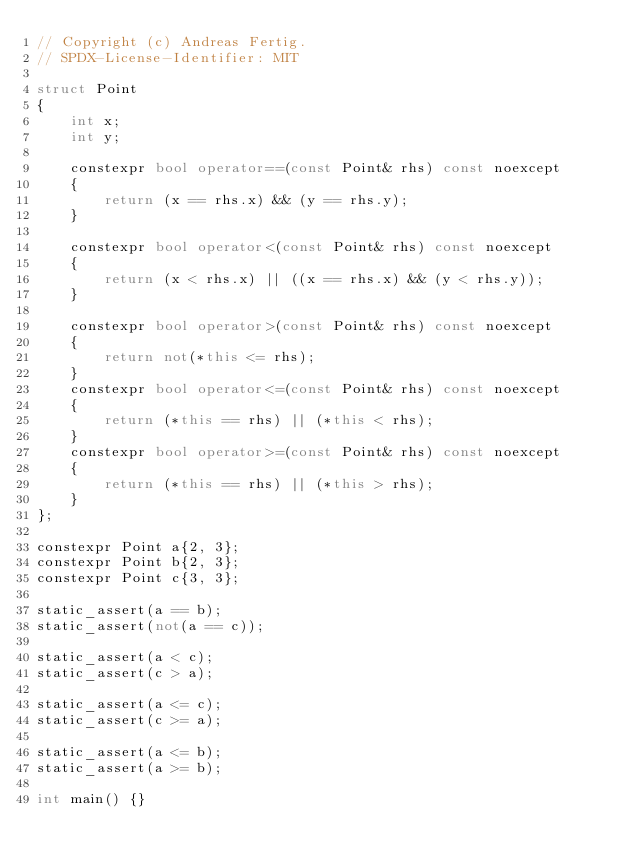<code> <loc_0><loc_0><loc_500><loc_500><_C++_>// Copyright (c) Andreas Fertig.
// SPDX-License-Identifier: MIT

struct Point
{
    int x;
    int y;

    constexpr bool operator==(const Point& rhs) const noexcept
    {
        return (x == rhs.x) && (y == rhs.y);
    }

    constexpr bool operator<(const Point& rhs) const noexcept
    {
        return (x < rhs.x) || ((x == rhs.x) && (y < rhs.y));
    }

    constexpr bool operator>(const Point& rhs) const noexcept
    {
        return not(*this <= rhs);
    }
    constexpr bool operator<=(const Point& rhs) const noexcept
    {
        return (*this == rhs) || (*this < rhs);
    }
    constexpr bool operator>=(const Point& rhs) const noexcept
    {
        return (*this == rhs) || (*this > rhs);
    }
};

constexpr Point a{2, 3};
constexpr Point b{2, 3};
constexpr Point c{3, 3};

static_assert(a == b);
static_assert(not(a == c));

static_assert(a < c);
static_assert(c > a);

static_assert(a <= c);
static_assert(c >= a);

static_assert(a <= b);
static_assert(a >= b);

int main() {}</code> 